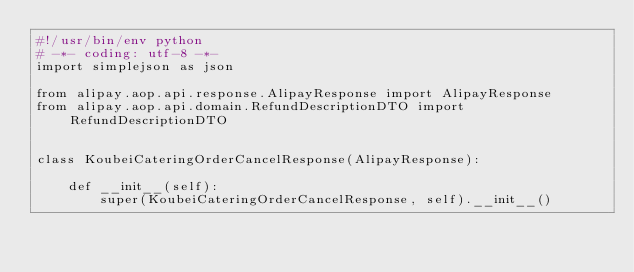<code> <loc_0><loc_0><loc_500><loc_500><_Python_>#!/usr/bin/env python
# -*- coding: utf-8 -*-
import simplejson as json

from alipay.aop.api.response.AlipayResponse import AlipayResponse
from alipay.aop.api.domain.RefundDescriptionDTO import RefundDescriptionDTO


class KoubeiCateringOrderCancelResponse(AlipayResponse):

    def __init__(self):
        super(KoubeiCateringOrderCancelResponse, self).__init__()</code> 